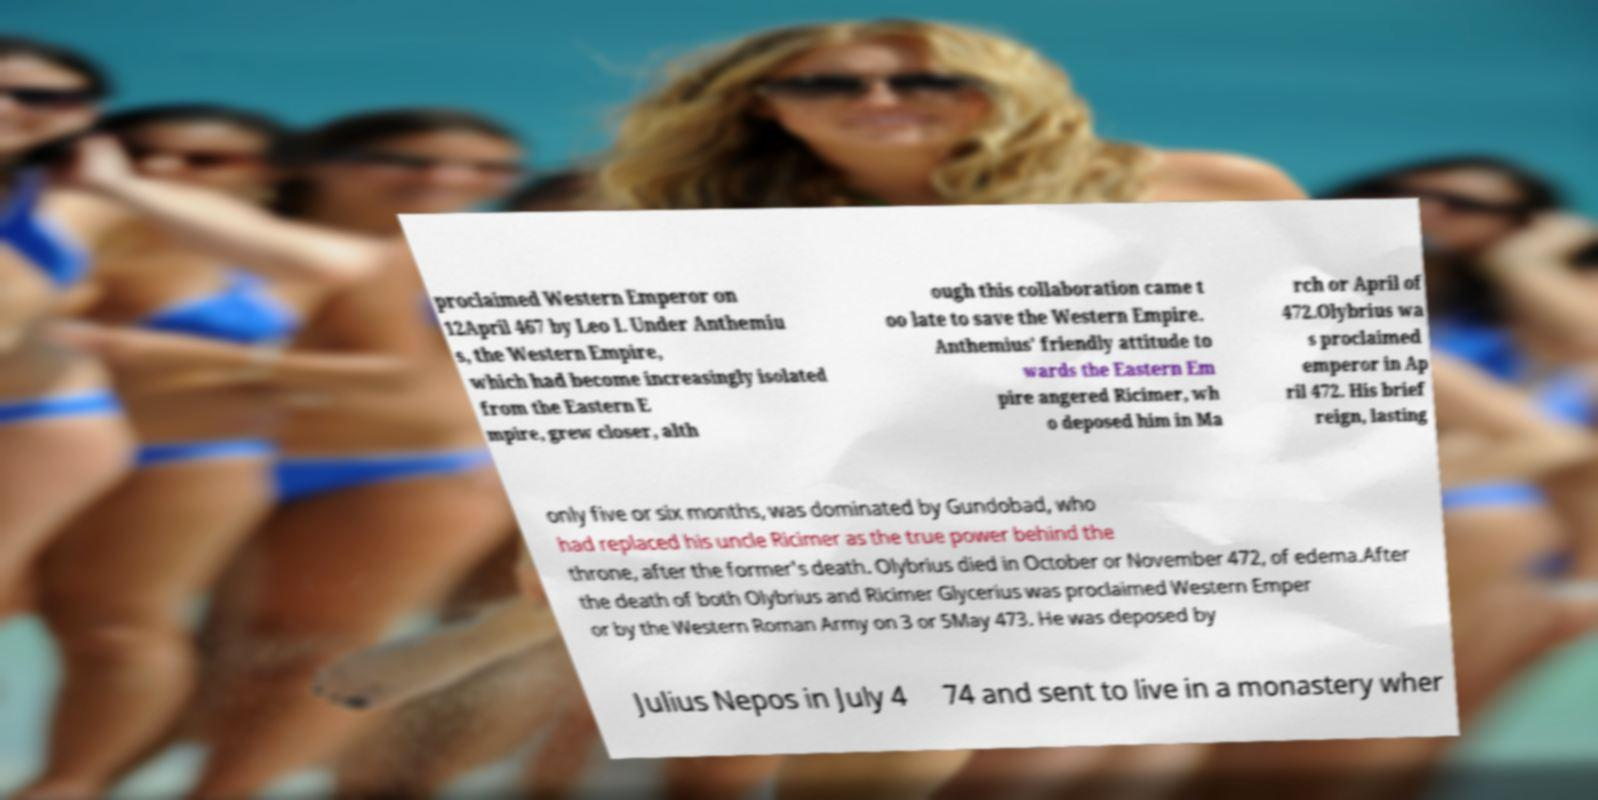There's text embedded in this image that I need extracted. Can you transcribe it verbatim? proclaimed Western Emperor on 12April 467 by Leo I. Under Anthemiu s, the Western Empire, which had become increasingly isolated from the Eastern E mpire, grew closer, alth ough this collaboration came t oo late to save the Western Empire. Anthemius' friendly attitude to wards the Eastern Em pire angered Ricimer, wh o deposed him in Ma rch or April of 472.Olybrius wa s proclaimed emperor in Ap ril 472. His brief reign, lasting only five or six months, was dominated by Gundobad, who had replaced his uncle Ricimer as the true power behind the throne, after the former's death. Olybrius died in October or November 472, of edema.After the death of both Olybrius and Ricimer Glycerius was proclaimed Western Emper or by the Western Roman Army on 3 or 5May 473. He was deposed by Julius Nepos in July 4 74 and sent to live in a monastery wher 